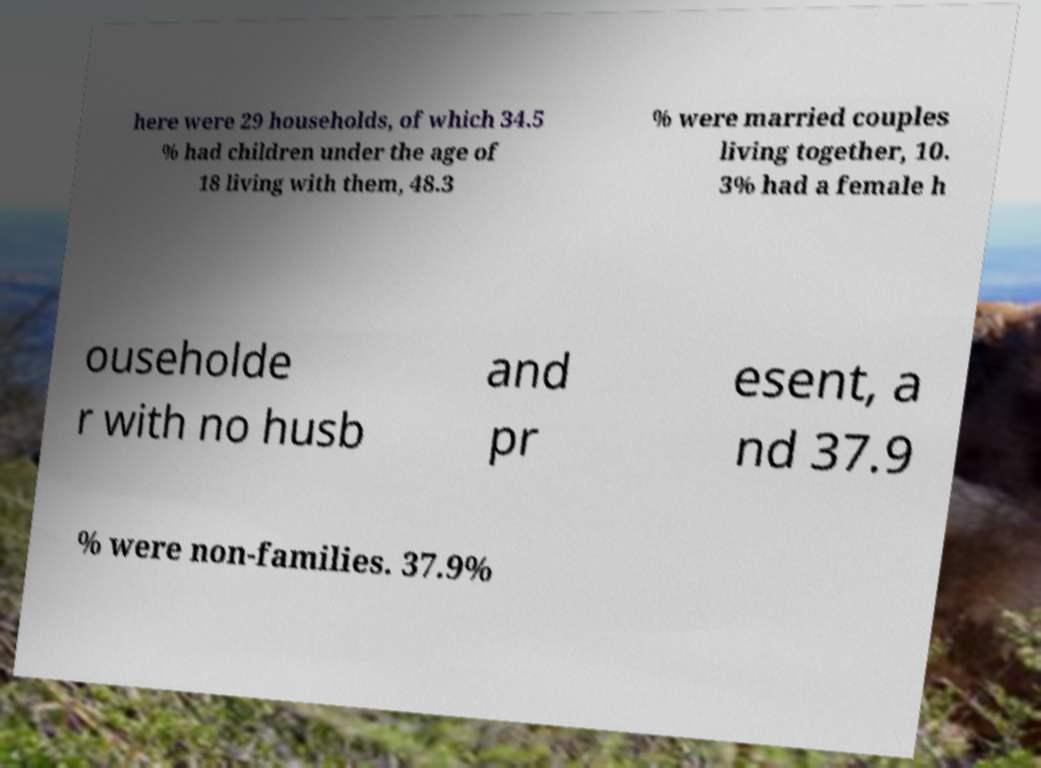Could you assist in decoding the text presented in this image and type it out clearly? here were 29 households, of which 34.5 % had children under the age of 18 living with them, 48.3 % were married couples living together, 10. 3% had a female h ouseholde r with no husb and pr esent, a nd 37.9 % were non-families. 37.9% 